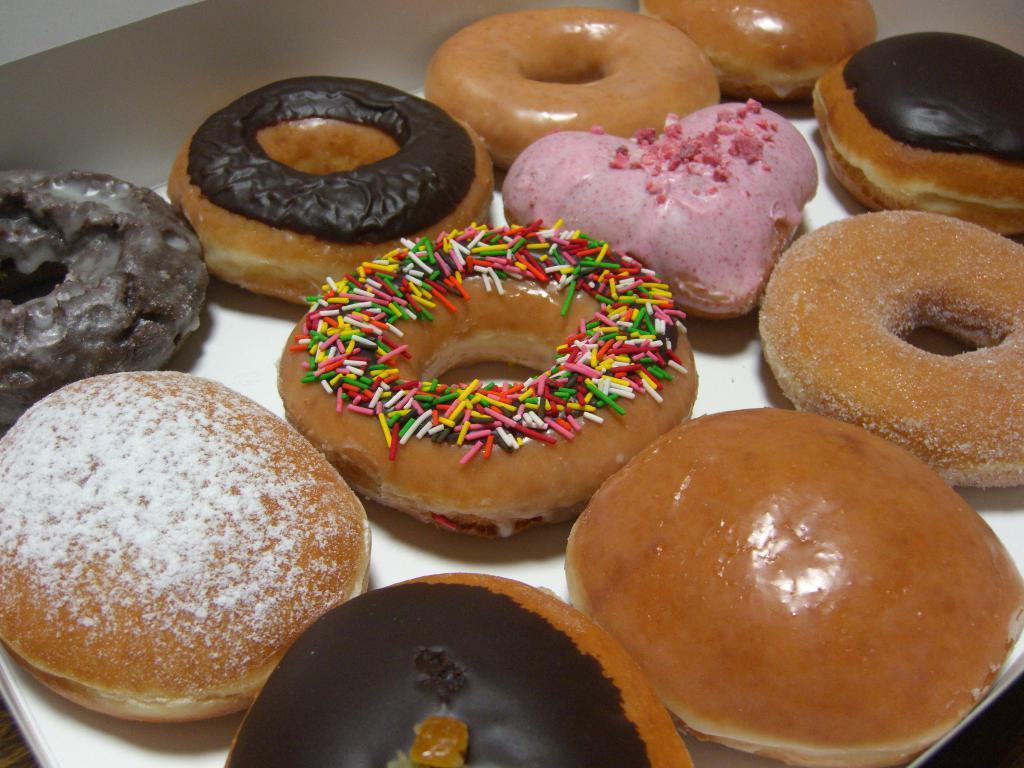Can you describe this image briefly? On this white surface we can see doughnuts. 